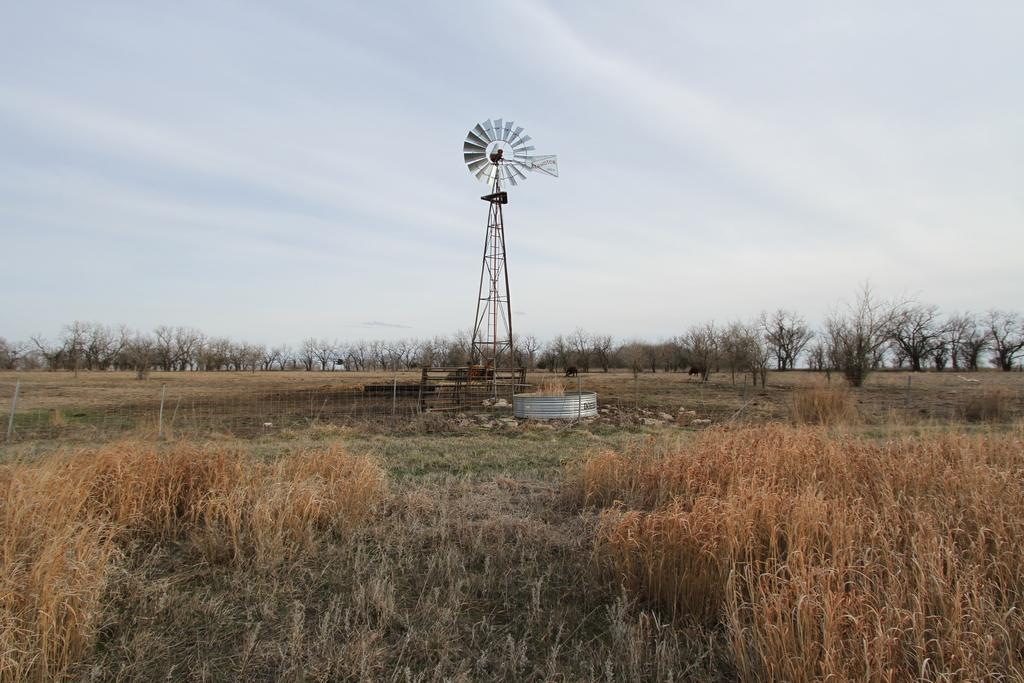What is the main structure visible in the image? There is a windmill in the image. What type of barrier can be seen in the image? There is a fence in the image. What type of vegetation is present in the image? There are trees in the image. What type of ground cover can be seen in the image? There is dried grass in the image. What is visible in the background of the image? The sky is visible in the image. What type of poison is being used to control the growth of the trees in the image? There is no mention of any poison being used to control the growth of trees in the image. The trees appear to be growing naturally. 